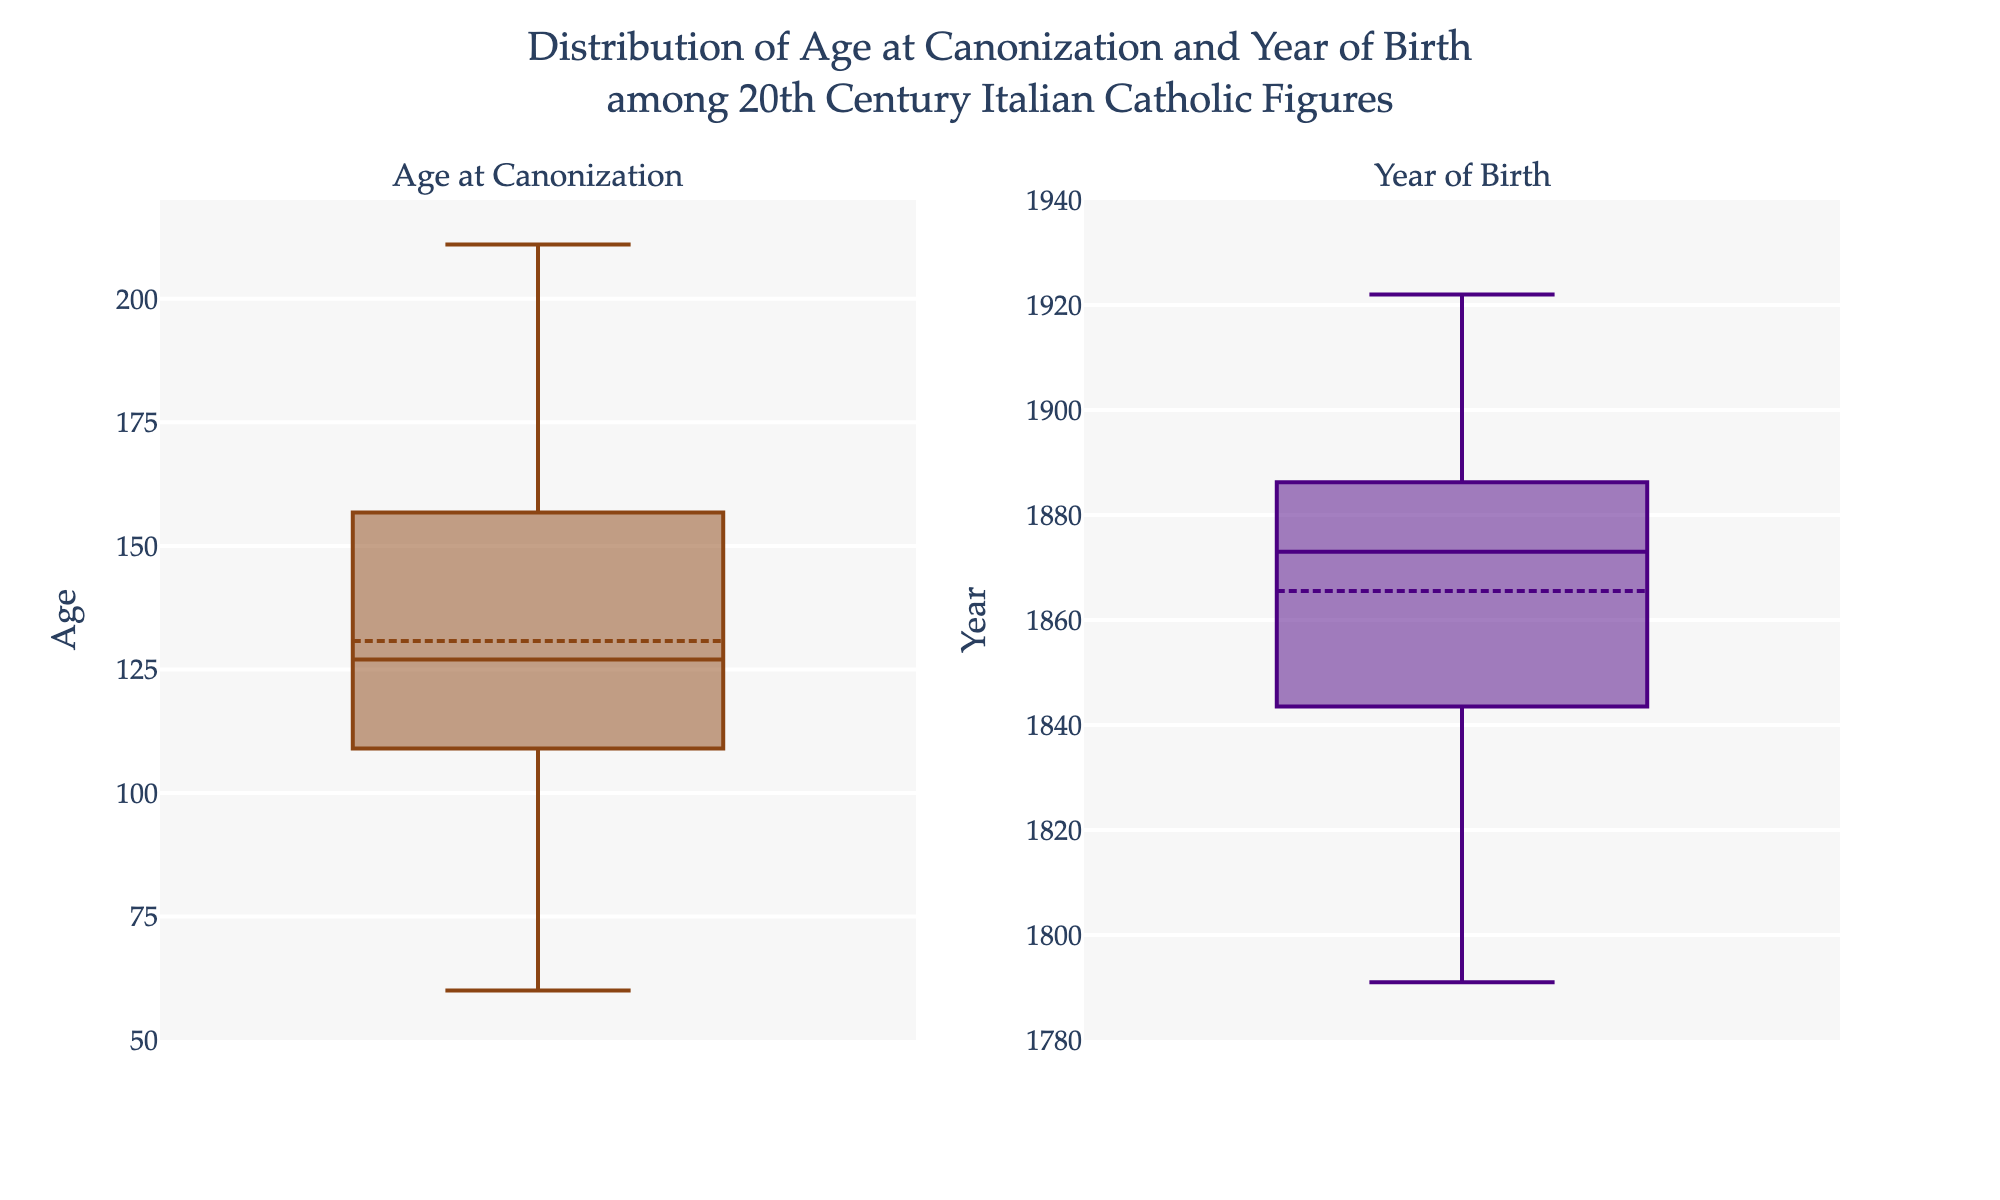what is the title of the plot? The title is displayed at the top center of the figure, usually in a larger and bolder font. It reads, "Distribution of Age at Canonization and Year of Birth among 20th Century Italian Catholic Figures."
Answer: Distribution of Age at Canonization and Year of Birth among 20th Century Italian Catholic Figures what is the range of the y-axis for Age at Canonization? The y-axis for Age at Canonization, located on the left side of the first subplot, ranges from 50 to 220, as indicated by the tick marks and labels.
Answer: 50 to 220 what is the color of the box plot for Year of Birth? The box plot for Year of Birth is marked in the color indigo. This can be observed from the color of the box plot in the second subplot.
Answer: Indigo how many data points are there in the Year of Birth box plot? There are 14 data points in the Year of Birth box plot, corresponding to the 14 individuals listed in the data. Each data point is shown as a small dot superimposed on the box plot.
Answer: 14 what is the median Age at Canonization? The median Age at Canonization is represented by the central line inside the box of the box plot for Age at Canonization. By examining this line, it's observed to be approximately 130 years.
Answer: 130 what is the average Year of Birth? The mean Year of Birth is represented by the symbol near the center of the box plot for Year of Birth. The box plot’s mean marker, combined with the annotation, indicates that it is around 1857.
Answer: 1857 who has the highest Age at Canonization? By examining the annotated figures for the Age at Canonization box plot, Benedetta Cambiagio Frassinello has the highest Age at Canonization at 211 years.
Answer: Benedetta Cambiagio Frassinello Compare the interquartile ranges (IQR) for Age at Canonization and Year of Birth. Which one is larger? The IQR is the range between the first quartile (Q1) and the third quartile (Q3). For Age at Canonization, it spans from around 105 to 150. For Year of Birth, it spans from about 1840 to 1880. The range for Age at Canonization is about 45 years while that for Year of Birth is about 40 years. Therefore, the IQR for Age at Canonization is slightly larger.
Answer: Age at Canonization 